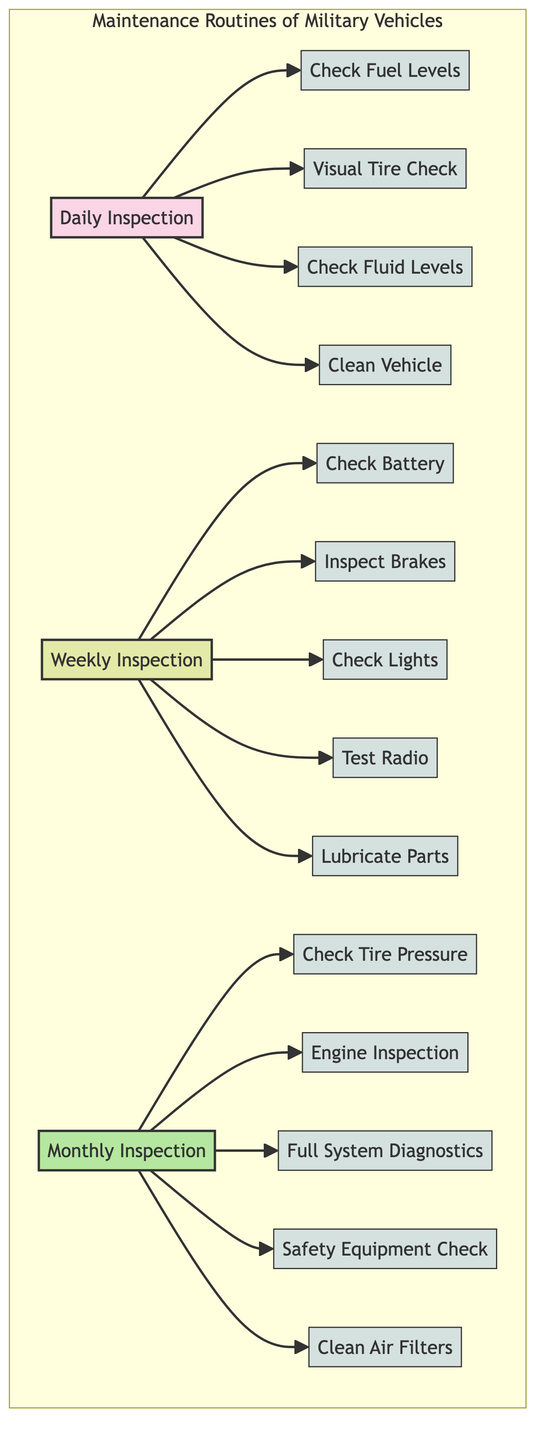What is the first task listed under daily inspection? According to the diagram, the first task connected to the "Daily Inspection" node is "Check Fuel Levels", indicating the order and priority of tasks.
Answer: Check Fuel Levels How many tasks are associated with the weekly inspection? The "Weekly Inspection" node connects to five distinct tasks, indicating the comprehensive nature of this routine maintenance check.
Answer: 5 What is the last task listed under monthly inspection? The last task connected to the "Monthly Inspection" node in the flowchart is "Clean Air Filters", showing that air quality is also a maintenance concern.
Answer: Clean Air Filters Which inspection includes checking the lights? The task "Check Lights" is connected to the "Weekly Inspection" node, implying that lights are considered during weekly maintenance routines.
Answer: Weekly Inspection How many types of inspections are represented in the diagram? The diagram includes three different types of inspections: daily, weekly, and monthly, clearly categorized in the maintenance routine structure.
Answer: 3 Which maintenance task occurs most frequently? Based on the diagram, tasks under "Daily Inspection" take place every day, making daily inspections the most frequent compared to weekly and monthly.
Answer: Daily Inspection What task is performed during both weekly and monthly inspections? There are no overlapping tasks between weekly and monthly inspections according to the diagram, indicating that all tasks are unique to their respective categories.
Answer: None Which tasks have the same level of maintenance frequency? The three types of tasks—daily, weekly, and monthly inspections—are distinct; however, the tasks within each category are equivalent in frequency for that category.
Answer: Daily, Weekly, Monthly 